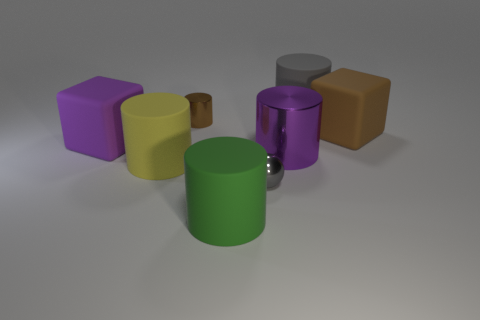There is a purple thing that is the same shape as the yellow thing; what is it made of?
Your answer should be very brief. Metal. Are there more large yellow things than large red metal things?
Your answer should be very brief. Yes. Is the big green thing made of the same material as the gray object that is in front of the gray rubber cylinder?
Ensure brevity in your answer.  No. There is a purple metallic cylinder that is to the right of the matte object in front of the large yellow matte thing; what number of purple matte objects are in front of it?
Provide a short and direct response. 0. Is the number of tiny gray metal things behind the big metallic thing less than the number of cubes that are in front of the large purple cube?
Provide a succinct answer. No. What number of other things are made of the same material as the big gray thing?
Provide a short and direct response. 4. There is another block that is the same size as the purple rubber cube; what material is it?
Your answer should be compact. Rubber. How many red things are either big objects or matte cubes?
Provide a succinct answer. 0. There is a thing that is both on the right side of the large green rubber cylinder and in front of the large yellow matte cylinder; what is its color?
Provide a short and direct response. Gray. Is the material of the purple thing on the left side of the green object the same as the yellow cylinder in front of the big gray thing?
Your answer should be compact. Yes. 